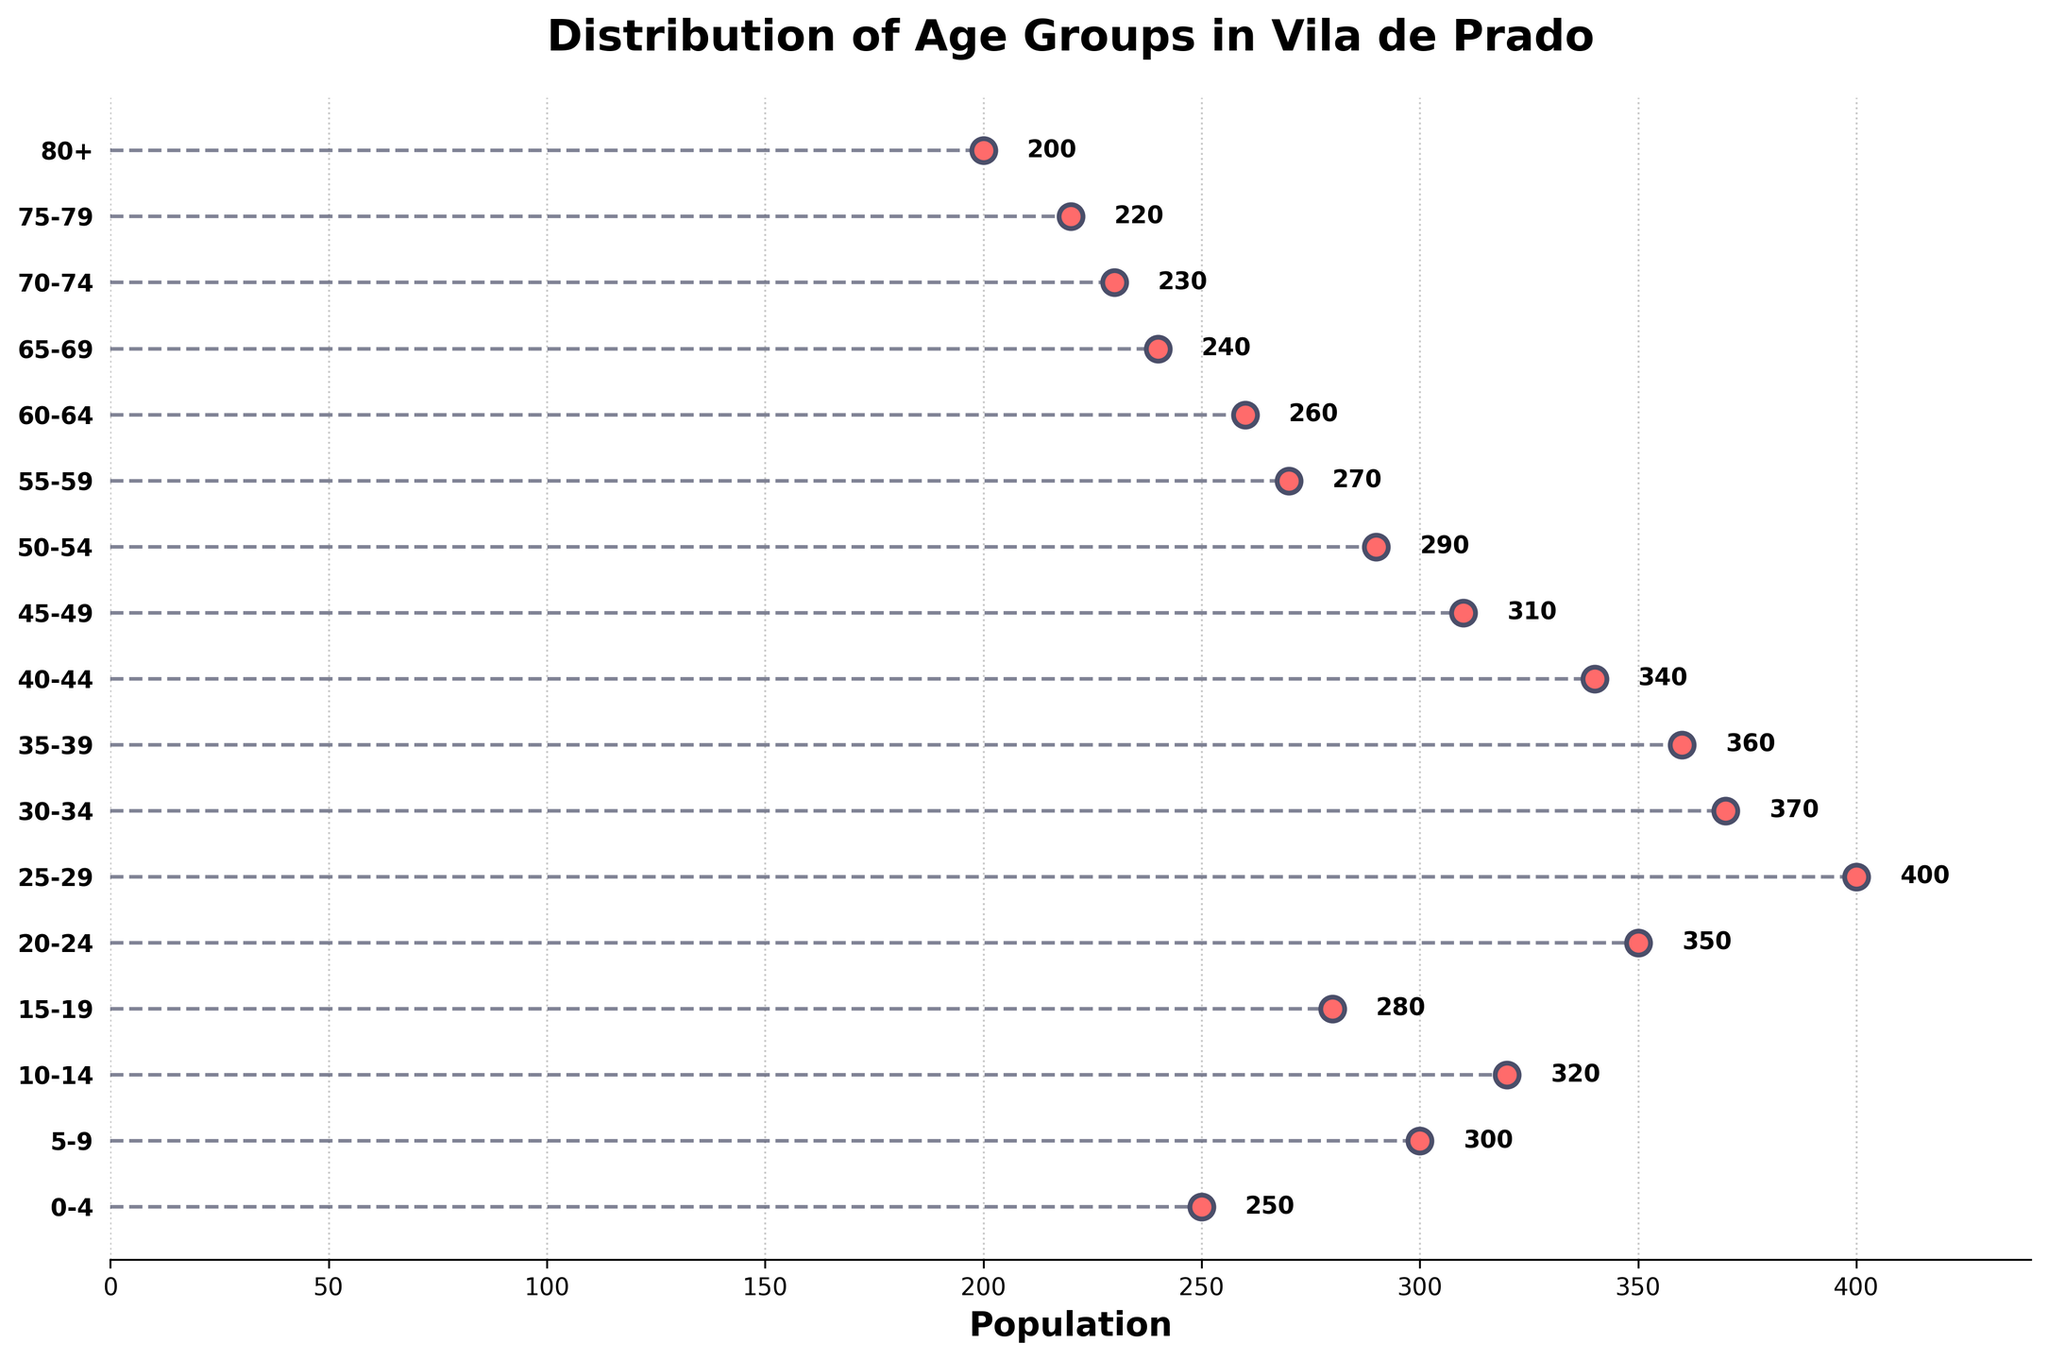What is the title of the plot? The title of the plot is located at the top and usually described in a larger, bold font.
Answer: Distribution of Age Groups in Vila de Prado Which age group has the highest population? By examining the scatter plot and the corresponding data labels, the age group with the highest population has the farthest dot to the right.
Answer: 25-29 Which age group has the lowest population? The age group with the lowest population is represented by the dot closest to the left along the x-axis.
Answer: 80+ How many age groups are presented in the plot? The number of distinct y-ticks or labels along the y-axis indicates the number of age groups.
Answer: 17 What is the population difference between the 25-29 and 80+ age groups? Find the populations of the 25-29 (400) and 80+ (200) groups from the plot and subtract the smaller from the larger. 400 - 200 = 200
Answer: 200 Is there an age group where the population is exactly 300? If yes, which one? Look for a dot on the scatter plot positioned at 300 on the x-axis and read the corresponding age group label.
Answer: 5-9 What is the combined population of the age groups 0-4 and 75-79? Add the populations of 0-4 (250) and 75-79 (220) from the plot. 250 + 220 = 470
Answer: 470 How does the population of the 20-24 age group compare to the 30-34 age group? Examine both dots related to 20-24 (350) and 30-34 (370) on the x-axis and compare the values. 370 > 350
Answer: 30-34 has a higher population Which age groups have a population greater than 300 but less than 350? Identify the dots that fall within the specified range along the x-axis and check their corresponding labels. These are the dots at 320 and 340.
Answer: 10-14, 40-44 What is the average population across all age groups? Sum all population values and divide by the number of age groups. Total population = 250 + 300 + 320 + 280 + 350 + 400 + 370 + 360 + 340 + 310 + 290 + 270 + 260 + 240 + 230 + 220 + 200 = 5290. Number of age groups = 17. Average population = 5290 / 17 ≈ 311
Answer: 311 